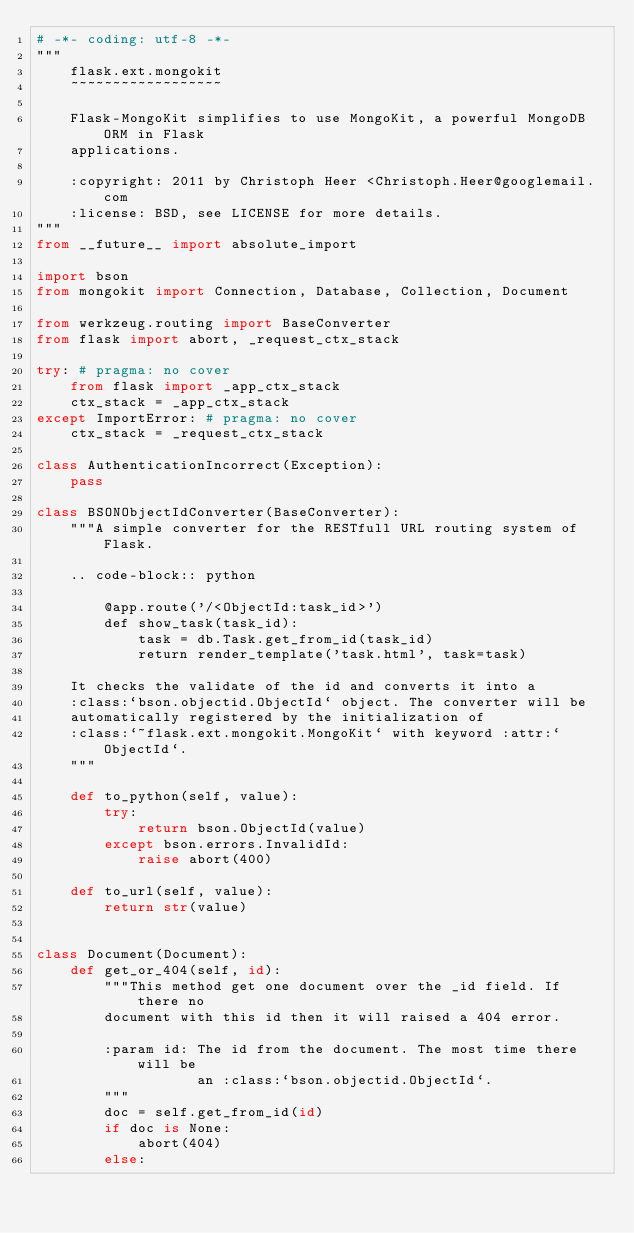Convert code to text. <code><loc_0><loc_0><loc_500><loc_500><_Python_># -*- coding: utf-8 -*-
"""
    flask.ext.mongokit
    ~~~~~~~~~~~~~~~~~~

    Flask-MongoKit simplifies to use MongoKit, a powerful MongoDB ORM in Flask
    applications.

    :copyright: 2011 by Christoph Heer <Christoph.Heer@googlemail.com
    :license: BSD, see LICENSE for more details.
"""
from __future__ import absolute_import

import bson
from mongokit import Connection, Database, Collection, Document

from werkzeug.routing import BaseConverter
from flask import abort, _request_ctx_stack

try: # pragma: no cover
    from flask import _app_ctx_stack
    ctx_stack = _app_ctx_stack
except ImportError: # pragma: no cover
    ctx_stack = _request_ctx_stack

class AuthenticationIncorrect(Exception):
    pass

class BSONObjectIdConverter(BaseConverter):
    """A simple converter for the RESTfull URL routing system of Flask.

    .. code-block:: python

        @app.route('/<ObjectId:task_id>')
        def show_task(task_id):
            task = db.Task.get_from_id(task_id)
            return render_template('task.html', task=task)

    It checks the validate of the id and converts it into a
    :class:`bson.objectid.ObjectId` object. The converter will be
    automatically registered by the initialization of
    :class:`~flask.ext.mongokit.MongoKit` with keyword :attr:`ObjectId`.
    """

    def to_python(self, value):
        try:
            return bson.ObjectId(value)
        except bson.errors.InvalidId:
            raise abort(400)

    def to_url(self, value):
        return str(value)


class Document(Document):
    def get_or_404(self, id):
        """This method get one document over the _id field. If there no
        document with this id then it will raised a 404 error.

        :param id: The id from the document. The most time there will be
                   an :class:`bson.objectid.ObjectId`.
        """
        doc = self.get_from_id(id)
        if doc is None:
            abort(404)
        else:</code> 